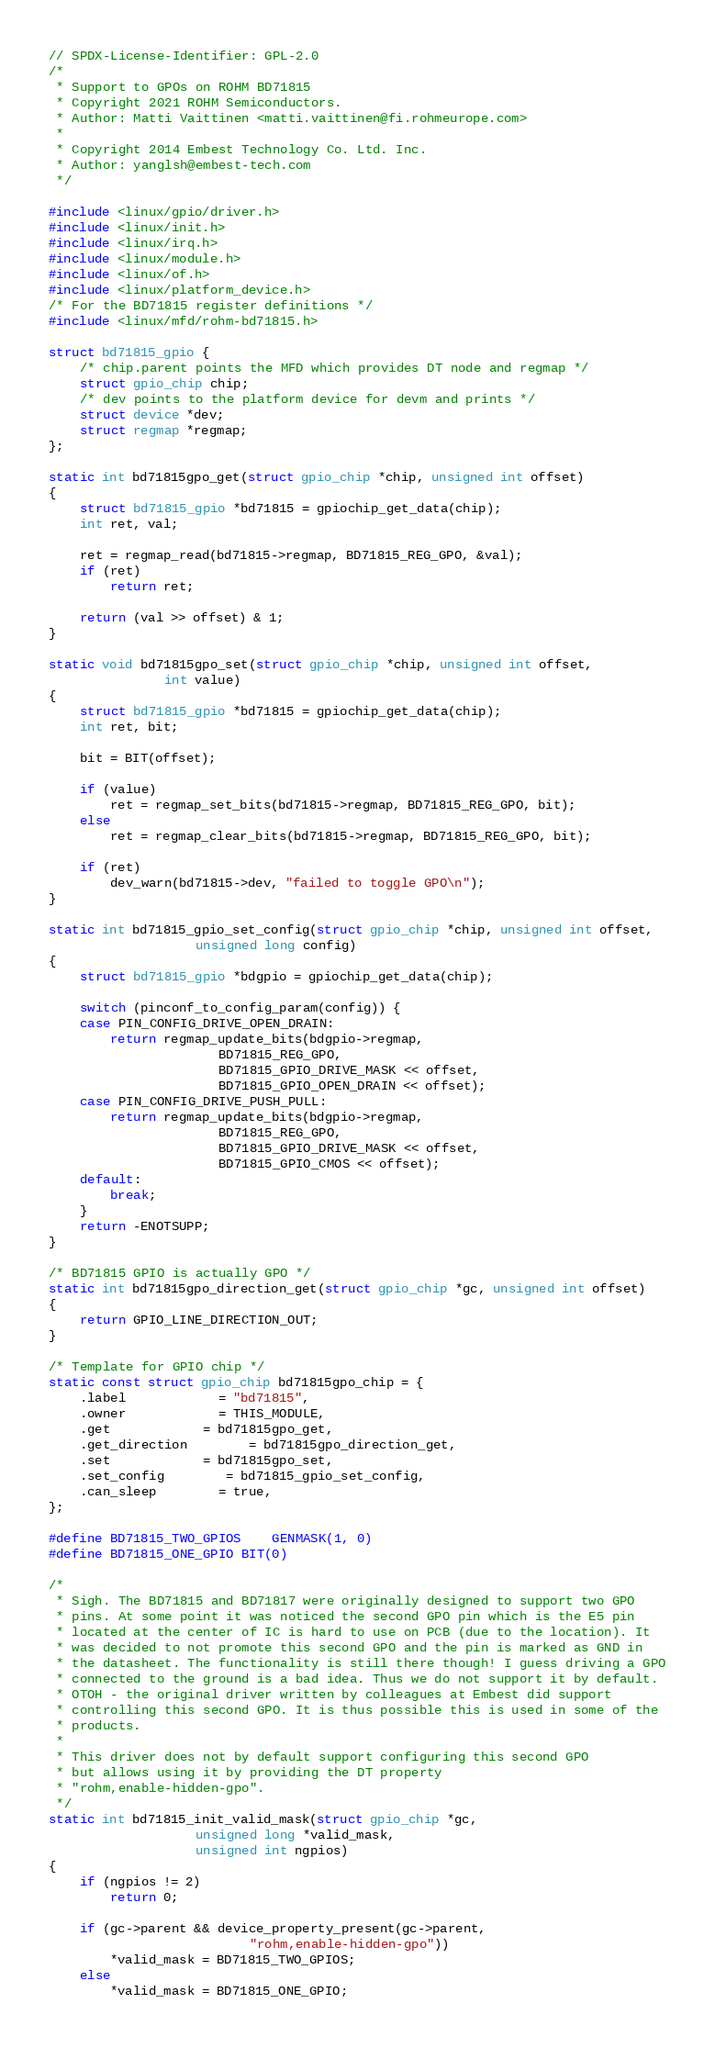Convert code to text. <code><loc_0><loc_0><loc_500><loc_500><_C_>// SPDX-License-Identifier: GPL-2.0
/*
 * Support to GPOs on ROHM BD71815
 * Copyright 2021 ROHM Semiconductors.
 * Author: Matti Vaittinen <matti.vaittinen@fi.rohmeurope.com>
 *
 * Copyright 2014 Embest Technology Co. Ltd. Inc.
 * Author: yanglsh@embest-tech.com
 */

#include <linux/gpio/driver.h>
#include <linux/init.h>
#include <linux/irq.h>
#include <linux/module.h>
#include <linux/of.h>
#include <linux/platform_device.h>
/* For the BD71815 register definitions */
#include <linux/mfd/rohm-bd71815.h>

struct bd71815_gpio {
	/* chip.parent points the MFD which provides DT node and regmap */
	struct gpio_chip chip;
	/* dev points to the platform device for devm and prints */
	struct device *dev;
	struct regmap *regmap;
};

static int bd71815gpo_get(struct gpio_chip *chip, unsigned int offset)
{
	struct bd71815_gpio *bd71815 = gpiochip_get_data(chip);
	int ret, val;

	ret = regmap_read(bd71815->regmap, BD71815_REG_GPO, &val);
	if (ret)
		return ret;

	return (val >> offset) & 1;
}

static void bd71815gpo_set(struct gpio_chip *chip, unsigned int offset,
			   int value)
{
	struct bd71815_gpio *bd71815 = gpiochip_get_data(chip);
	int ret, bit;

	bit = BIT(offset);

	if (value)
		ret = regmap_set_bits(bd71815->regmap, BD71815_REG_GPO, bit);
	else
		ret = regmap_clear_bits(bd71815->regmap, BD71815_REG_GPO, bit);

	if (ret)
		dev_warn(bd71815->dev, "failed to toggle GPO\n");
}

static int bd71815_gpio_set_config(struct gpio_chip *chip, unsigned int offset,
				   unsigned long config)
{
	struct bd71815_gpio *bdgpio = gpiochip_get_data(chip);

	switch (pinconf_to_config_param(config)) {
	case PIN_CONFIG_DRIVE_OPEN_DRAIN:
		return regmap_update_bits(bdgpio->regmap,
					  BD71815_REG_GPO,
					  BD71815_GPIO_DRIVE_MASK << offset,
					  BD71815_GPIO_OPEN_DRAIN << offset);
	case PIN_CONFIG_DRIVE_PUSH_PULL:
		return regmap_update_bits(bdgpio->regmap,
					  BD71815_REG_GPO,
					  BD71815_GPIO_DRIVE_MASK << offset,
					  BD71815_GPIO_CMOS << offset);
	default:
		break;
	}
	return -ENOTSUPP;
}

/* BD71815 GPIO is actually GPO */
static int bd71815gpo_direction_get(struct gpio_chip *gc, unsigned int offset)
{
	return GPIO_LINE_DIRECTION_OUT;
}

/* Template for GPIO chip */
static const struct gpio_chip bd71815gpo_chip = {
	.label			= "bd71815",
	.owner			= THIS_MODULE,
	.get			= bd71815gpo_get,
	.get_direction		= bd71815gpo_direction_get,
	.set			= bd71815gpo_set,
	.set_config		= bd71815_gpio_set_config,
	.can_sleep		= true,
};

#define BD71815_TWO_GPIOS	GENMASK(1, 0)
#define BD71815_ONE_GPIO	BIT(0)

/*
 * Sigh. The BD71815 and BD71817 were originally designed to support two GPO
 * pins. At some point it was noticed the second GPO pin which is the E5 pin
 * located at the center of IC is hard to use on PCB (due to the location). It
 * was decided to not promote this second GPO and the pin is marked as GND in
 * the datasheet. The functionality is still there though! I guess driving a GPO
 * connected to the ground is a bad idea. Thus we do not support it by default.
 * OTOH - the original driver written by colleagues at Embest did support
 * controlling this second GPO. It is thus possible this is used in some of the
 * products.
 *
 * This driver does not by default support configuring this second GPO
 * but allows using it by providing the DT property
 * "rohm,enable-hidden-gpo".
 */
static int bd71815_init_valid_mask(struct gpio_chip *gc,
				   unsigned long *valid_mask,
				   unsigned int ngpios)
{
	if (ngpios != 2)
		return 0;

	if (gc->parent && device_property_present(gc->parent,
						  "rohm,enable-hidden-gpo"))
		*valid_mask = BD71815_TWO_GPIOS;
	else
		*valid_mask = BD71815_ONE_GPIO;
</code> 